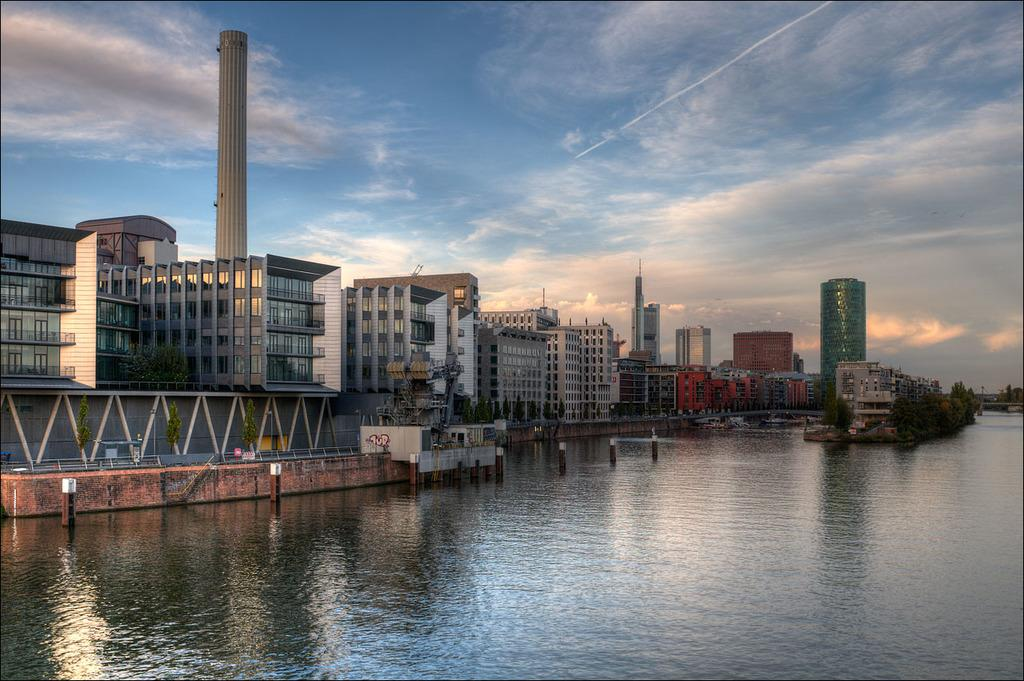What is visible in the image? Water is visible in the image. What can be seen in the background of the image? There are trees and buildings in the background of the image. What is the color of the trees in the image? The trees are green in color. What is the color of the sky in the image? The sky is blue and white in color. Where is the pen located in the image? There is no pen present in the image. Can you tell me the profession of the judge in the image? There is no judge present in the image. 